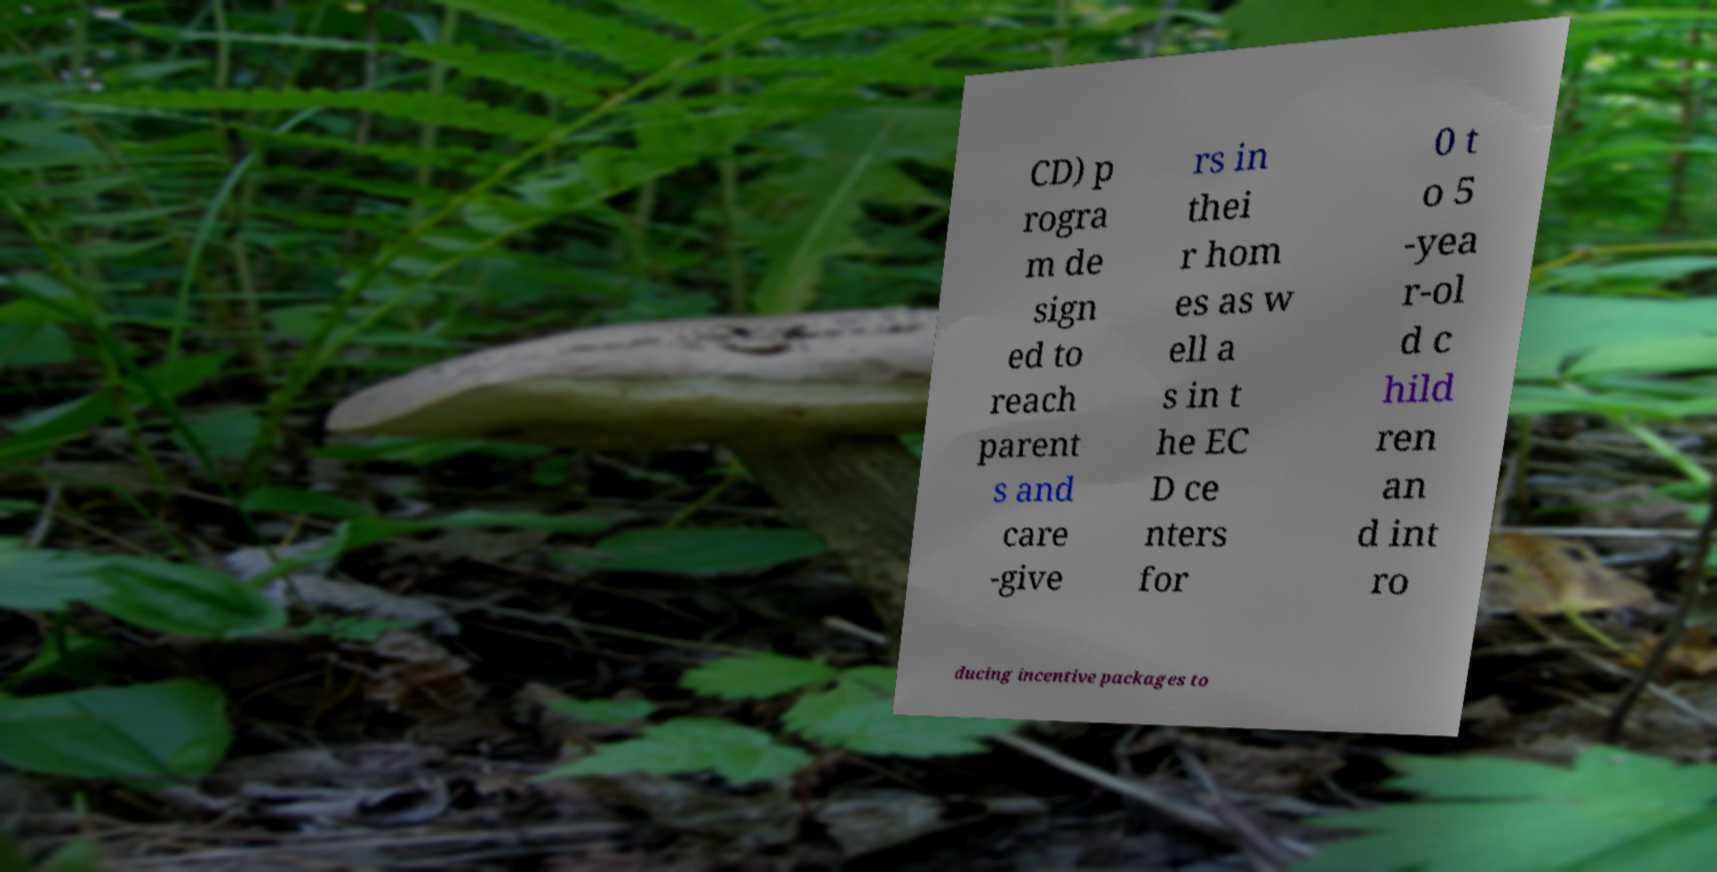Please identify and transcribe the text found in this image. CD) p rogra m de sign ed to reach parent s and care -give rs in thei r hom es as w ell a s in t he EC D ce nters for 0 t o 5 -yea r-ol d c hild ren an d int ro ducing incentive packages to 